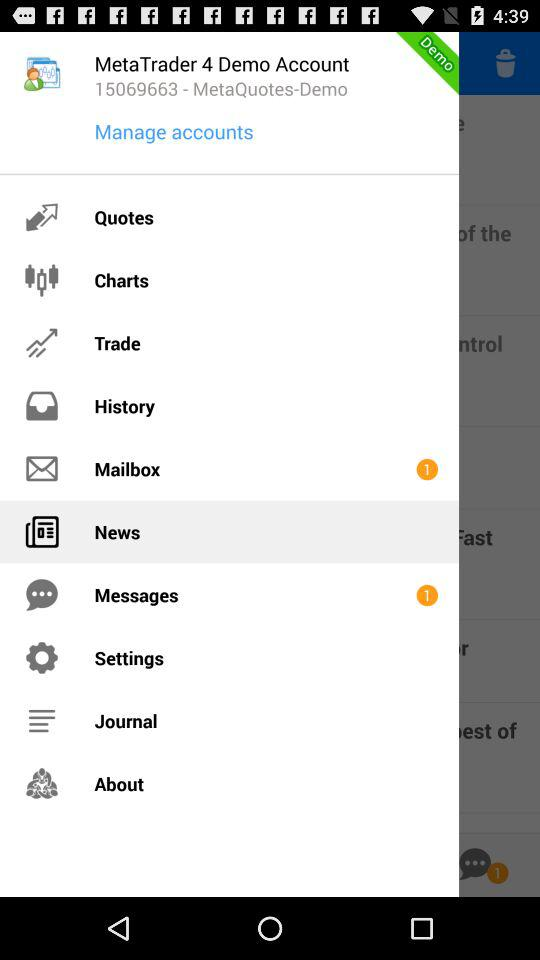How many unread messages are in "Mailbox"? There is 1 unread message. 